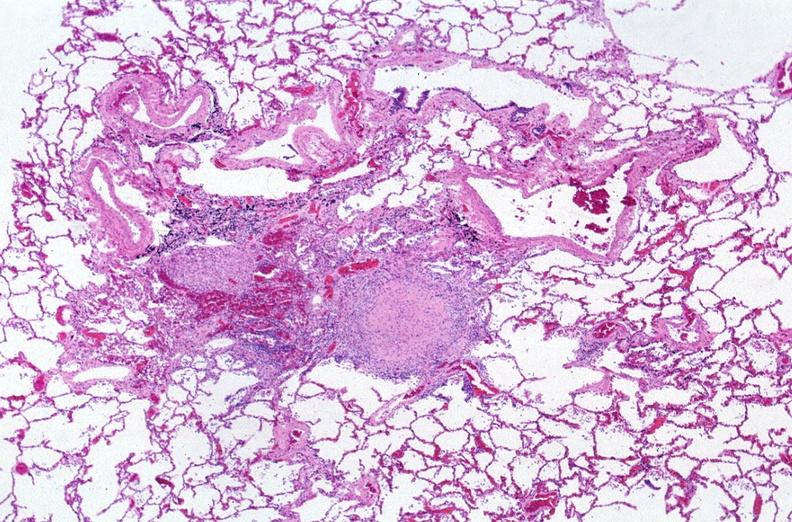what is present?
Answer the question using a single word or phrase. Respiratory 